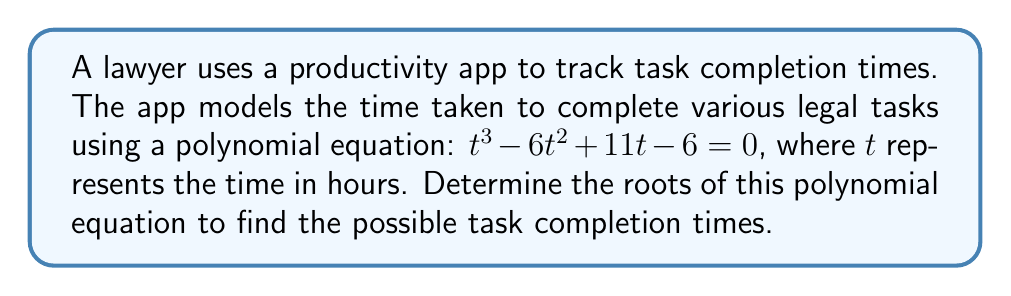Provide a solution to this math problem. To find the roots of the polynomial equation $t^3 - 6t^2 + 11t - 6 = 0$, we'll use the following steps:

1) First, let's check if there are any rational roots using the rational root theorem. The possible rational roots are the factors of the constant term (6): ±1, ±2, ±3, ±6.

2) Testing these values, we find that $t = 1$ is a root:
   $1^3 - 6(1)^2 + 11(1) - 6 = 1 - 6 + 11 - 6 = 0$

3) Since $t = 1$ is a root, we can factor out $(t - 1)$:
   $t^3 - 6t^2 + 11t - 6 = (t - 1)(t^2 - 5t + 6)$

4) Now we need to solve the quadratic equation $t^2 - 5t + 6 = 0$

5) We can solve this using the quadratic formula: $t = \frac{-b \pm \sqrt{b^2 - 4ac}}{2a}$
   Where $a = 1$, $b = -5$, and $c = 6$

6) Substituting these values:
   $t = \frac{5 \pm \sqrt{25 - 24}}{2} = \frac{5 \pm 1}{2}$

7) This gives us two more roots:
   $t = \frac{5 + 1}{2} = 3$ and $t = \frac{5 - 1}{2} = 2$

Therefore, the roots of the polynomial equation are 1, 2, and 3.
Answer: $t = 1, 2, 3$ 